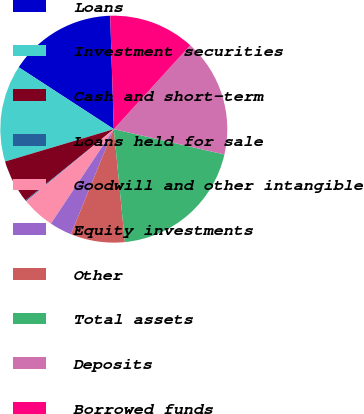Convert chart. <chart><loc_0><loc_0><loc_500><loc_500><pie_chart><fcel>Loans<fcel>Investment securities<fcel>Cash and short-term<fcel>Loans held for sale<fcel>Goodwill and other intangible<fcel>Equity investments<fcel>Other<fcel>Total assets<fcel>Deposits<fcel>Borrowed funds<nl><fcel>15.31%<fcel>13.79%<fcel>6.21%<fcel>0.14%<fcel>4.69%<fcel>3.18%<fcel>7.73%<fcel>19.86%<fcel>16.82%<fcel>12.27%<nl></chart> 